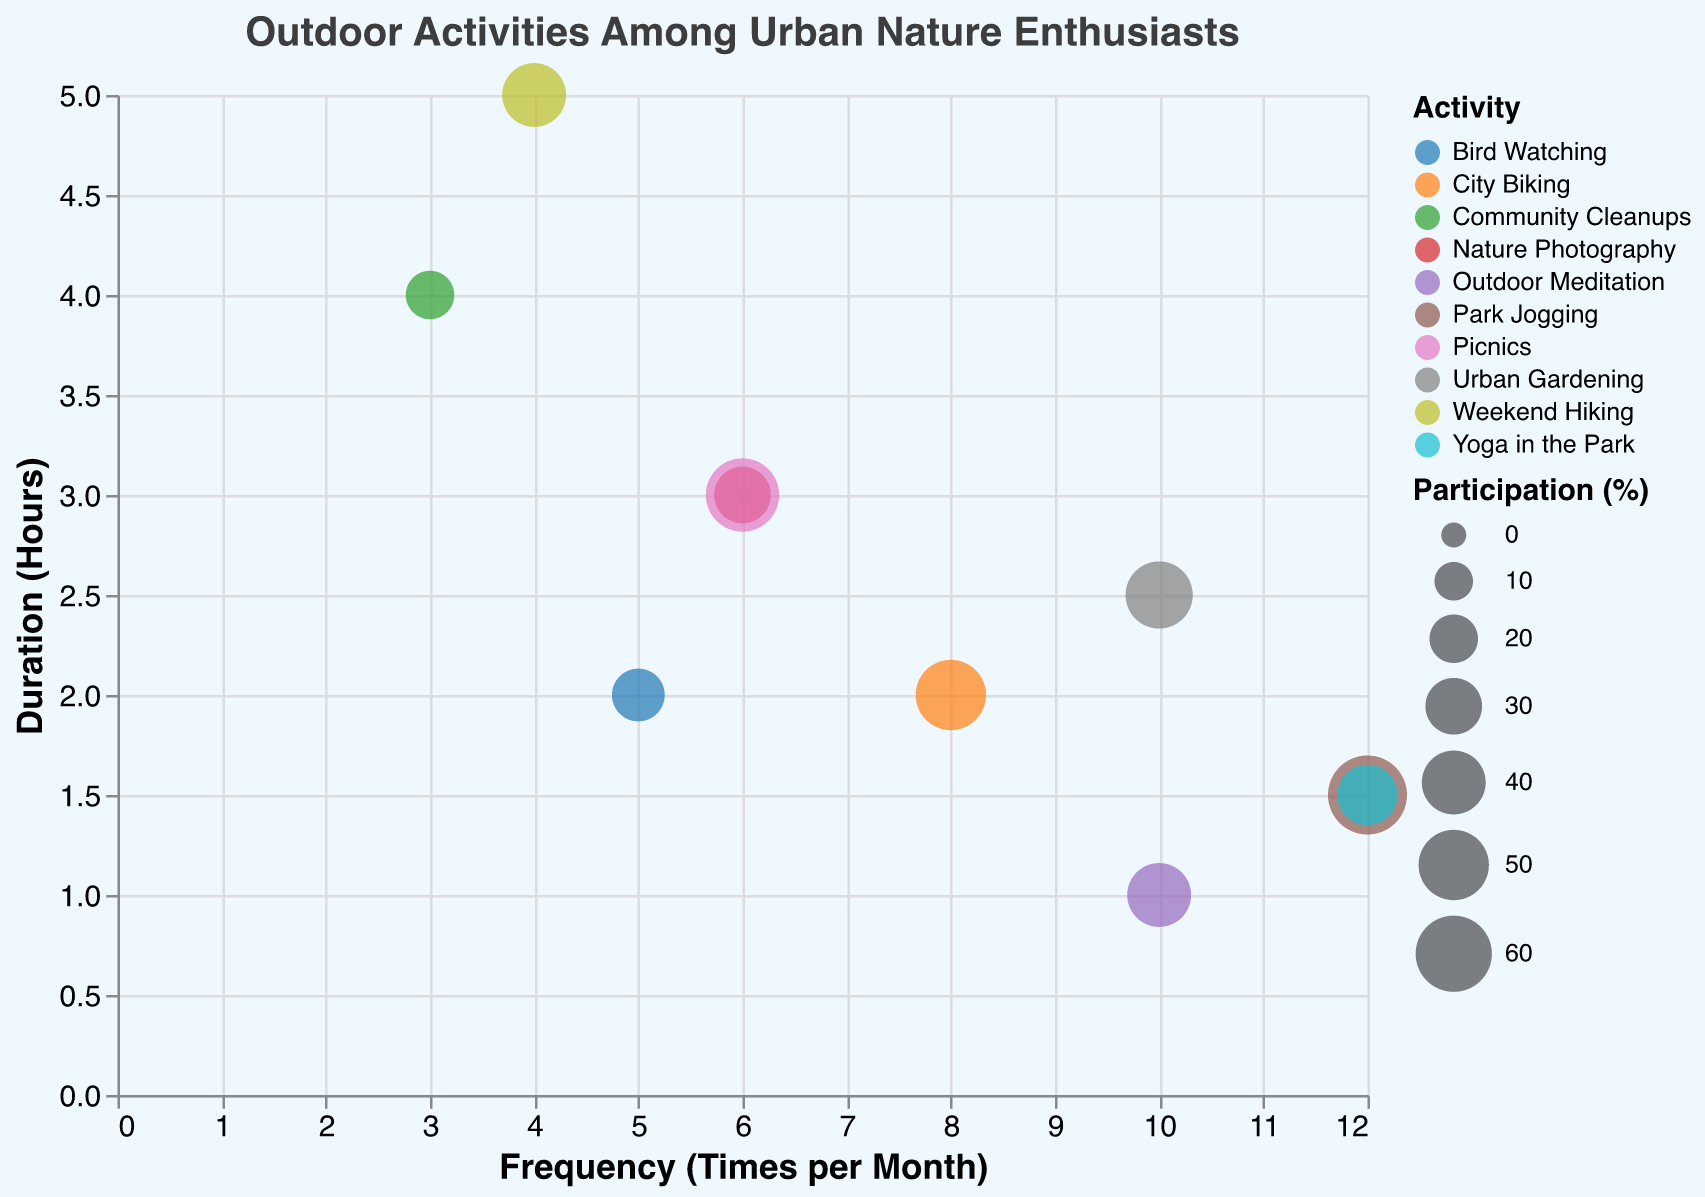What's the title of the chart? Look at the upper part of the figure where the title is usually located.
Answer: Outdoor Activities Among Urban Nature Enthusiasts How many activities are represented in the chart? Count the number of different colored bubbles, each representing a different activity.
Answer: 10 Which activity has the highest participation percentage? Look for the largest bubble, which represents the activity with the highest participation percentage.
Answer: Park Jogging Which activity is performed most frequently per month? Identify the bubble positioned farthest to the right on the x-axis, indicating the highest frequency.
Answer: Park Jogging / Yoga in the Park (both have a frequency of 12 times per month) Which activity has the longest average duration? Find the bubble that is positioned highest on the y-axis, indicating the longest duration.
Answer: Weekend Hiking Which activity has equal participation percentage but different frequency and duration compared to Park Jogging? Look for another activity with the same bubble size as Park Jogging but different x and y coordinates.
Answer: Yoga in the Park What is the combined frequency of City Biking and Urban Gardening? Add the frequency of City Biking (8 times per month) and Urban Gardening (10 times per month).
Answer: 18 Which has a higher average monthly duration, Bird Watching or Nature Photography? Divide the total duration by the frequency for each activity and compare the results: Bird Watching (2 hours * 5 times = 10 hours total, 10/5 = 2 hours per session) and Nature Photography (3 hours * 6 times = 18 hours total, 18/6 = 3 hours per session).
Answer: Nature Photography Which activity has the smallest participation percentage? Identify the smallest bubble in the chart.
Answer: Community Cleanups What's the median frequency of all activities in the chart? List the frequencies in ascending order: 3, 4, 5, 6, 6, 8, 10, 10, 12, 12, and identify the middle value. Since there are 10 data points, the median is the average of the 5th and 6th values (6 and 8).
Answer: 7 